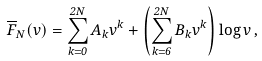<formula> <loc_0><loc_0><loc_500><loc_500>\overline { F } _ { N } ( v ) = \sum _ { k = 0 } ^ { 2 N } A _ { k } v ^ { k } + \left ( \sum _ { k = 6 } ^ { 2 N } B _ { k } v ^ { k } \right ) \log v \, ,</formula> 